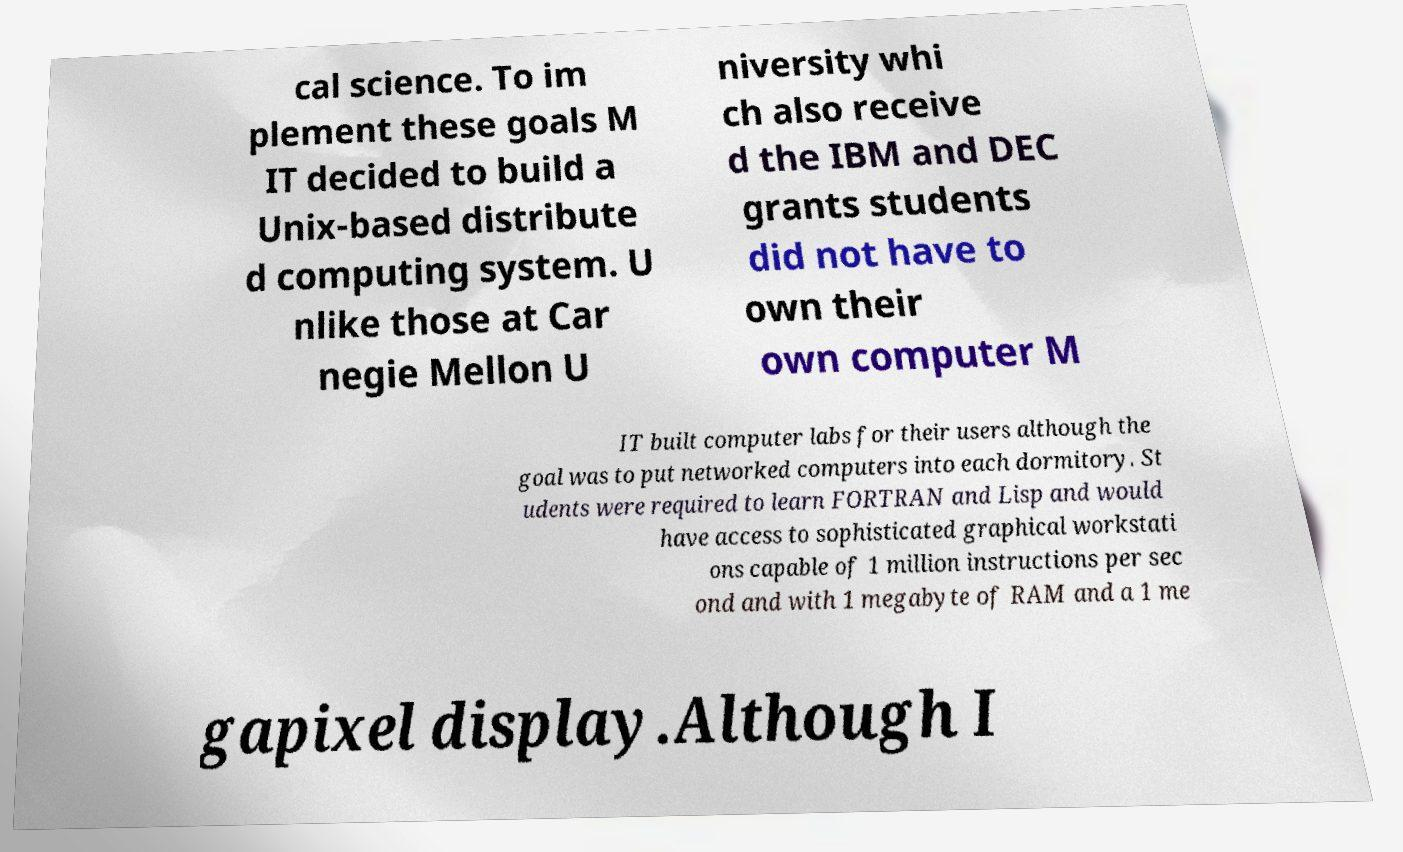There's text embedded in this image that I need extracted. Can you transcribe it verbatim? cal science. To im plement these goals M IT decided to build a Unix-based distribute d computing system. U nlike those at Car negie Mellon U niversity whi ch also receive d the IBM and DEC grants students did not have to own their own computer M IT built computer labs for their users although the goal was to put networked computers into each dormitory. St udents were required to learn FORTRAN and Lisp and would have access to sophisticated graphical workstati ons capable of 1 million instructions per sec ond and with 1 megabyte of RAM and a 1 me gapixel display.Although I 